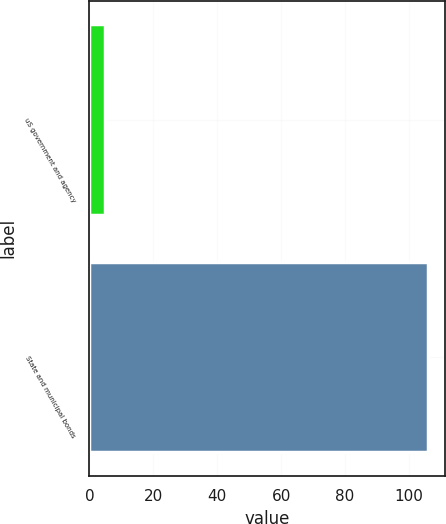Convert chart to OTSL. <chart><loc_0><loc_0><loc_500><loc_500><bar_chart><fcel>uS government and agency<fcel>State and municipal bonds<nl><fcel>5<fcel>106<nl></chart> 